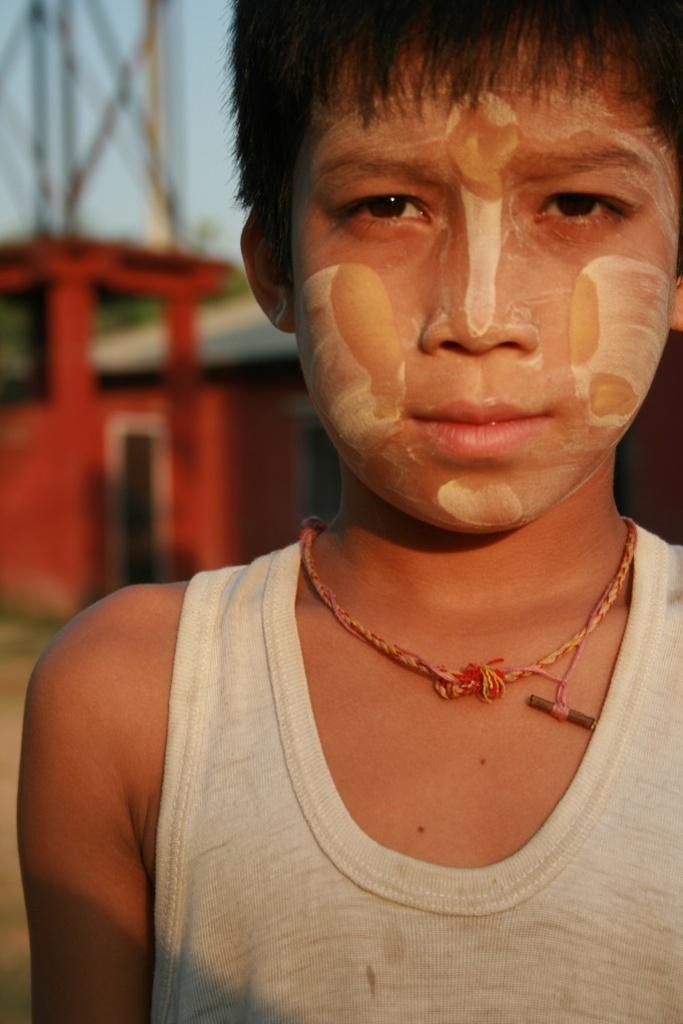Please provide a concise description of this image. This is a zoomed in picture. In the foreground there is a kid seems to be standing on the ground. In the background we can see the sky, metal rods and a red color object seems to be a house. 